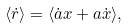Convert formula to latex. <formula><loc_0><loc_0><loc_500><loc_500>\langle \dot { r } \rangle = \langle \dot { a } x + a \dot { x } \rangle ,</formula> 